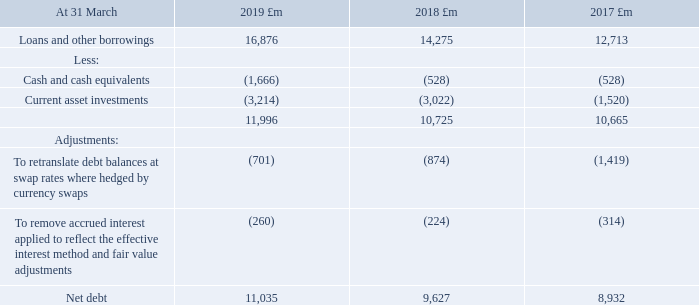25. Loans and other borrowings continued
Net Debt
Net debt consists of loans and other borrowings (both current and non-current), less current asset investments and cash and cash equivalents. Loans and other borrowings are measured at the net proceeds raised, adjusted to amortise any discount over the term of the debt. For the purpose of this measure, current asset investments and cash and cash equivalents are measured at the lower of cost and net realisable value. Currency denominated balances within net debt are translated to sterling at swapped rates where hedged.
Net debt is considered to be an alternative performance measure as it is not defined in IFRS. The most directly comparable IFRS measure is the aggregate of loans and other borrowings (current and non-current), current asset investments and cash and cash equivalents. A reconciliation from the most directly comparable IFRS measure to net debt is given below.
A reconciliation from the most directly comparable IFRS measure to net debt is given below.
How is net debt calculated? Loans and other borrowings (both current and non-current), less current asset investments and cash and cash equivalents. What was the Loans and other borrowings in 2019, 2018 and 2017?
Answer scale should be: million. 16,876, 14,275, 12,713. For what years are information about  Loans and other borrowings provided? 2019, 2018, 2017. What was the change in the Loans and other borrowings from 2018 to 2019?
Answer scale should be: million. 16,876 - 14,275
Answer: 2601. What is the average Cash and cash equivalents for 2017-2019?
Answer scale should be: million. -(1,666 + 528 + 528) / 3
Answer: -907.33. What is the percentage change in the Net debt from 2018 to 2019?
Answer scale should be: percent. 11,035 / 9,627 - 1
Answer: 14.63. 